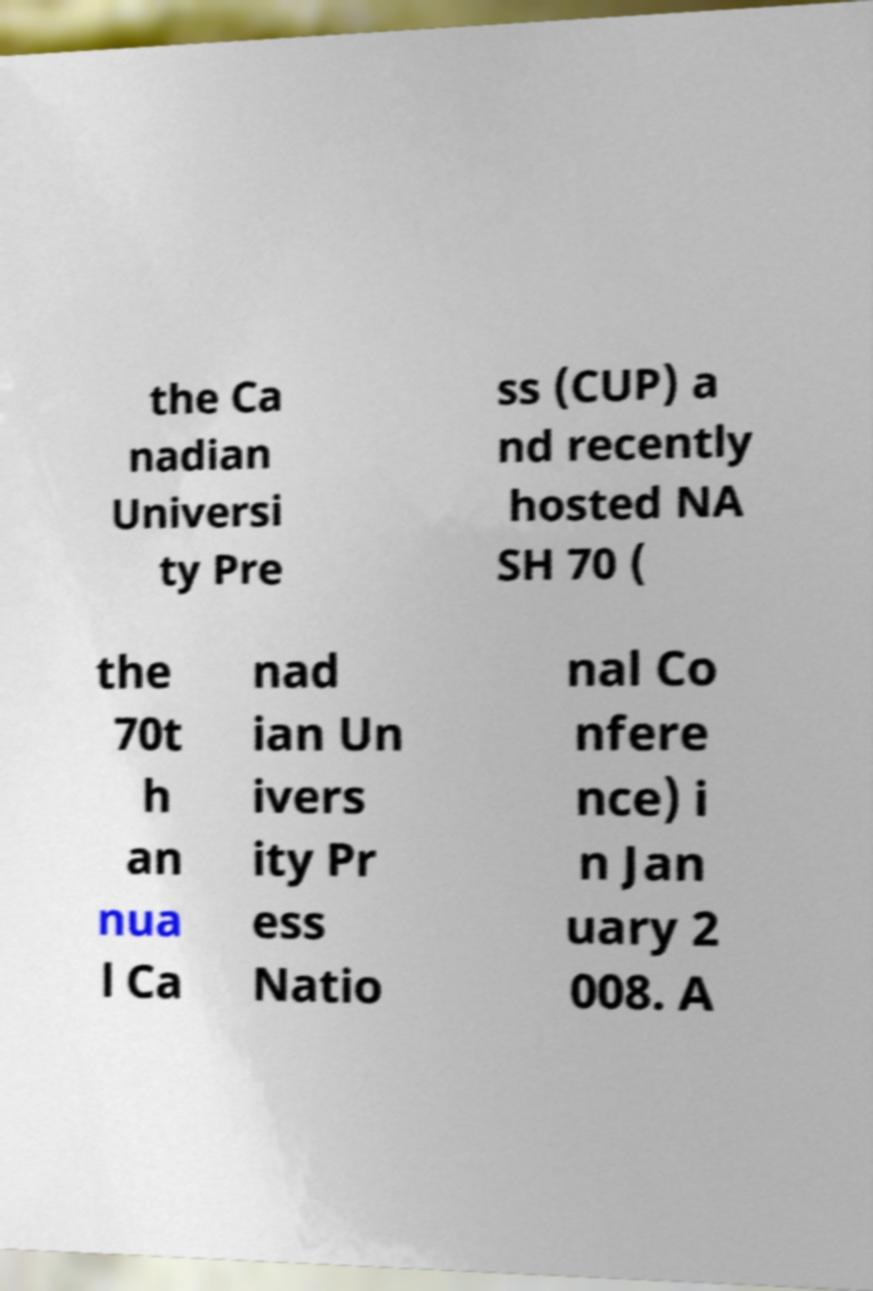I need the written content from this picture converted into text. Can you do that? the Ca nadian Universi ty Pre ss (CUP) a nd recently hosted NA SH 70 ( the 70t h an nua l Ca nad ian Un ivers ity Pr ess Natio nal Co nfere nce) i n Jan uary 2 008. A 